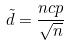Convert formula to latex. <formula><loc_0><loc_0><loc_500><loc_500>\tilde { d } = \frac { n c p } { \sqrt { n } }</formula> 